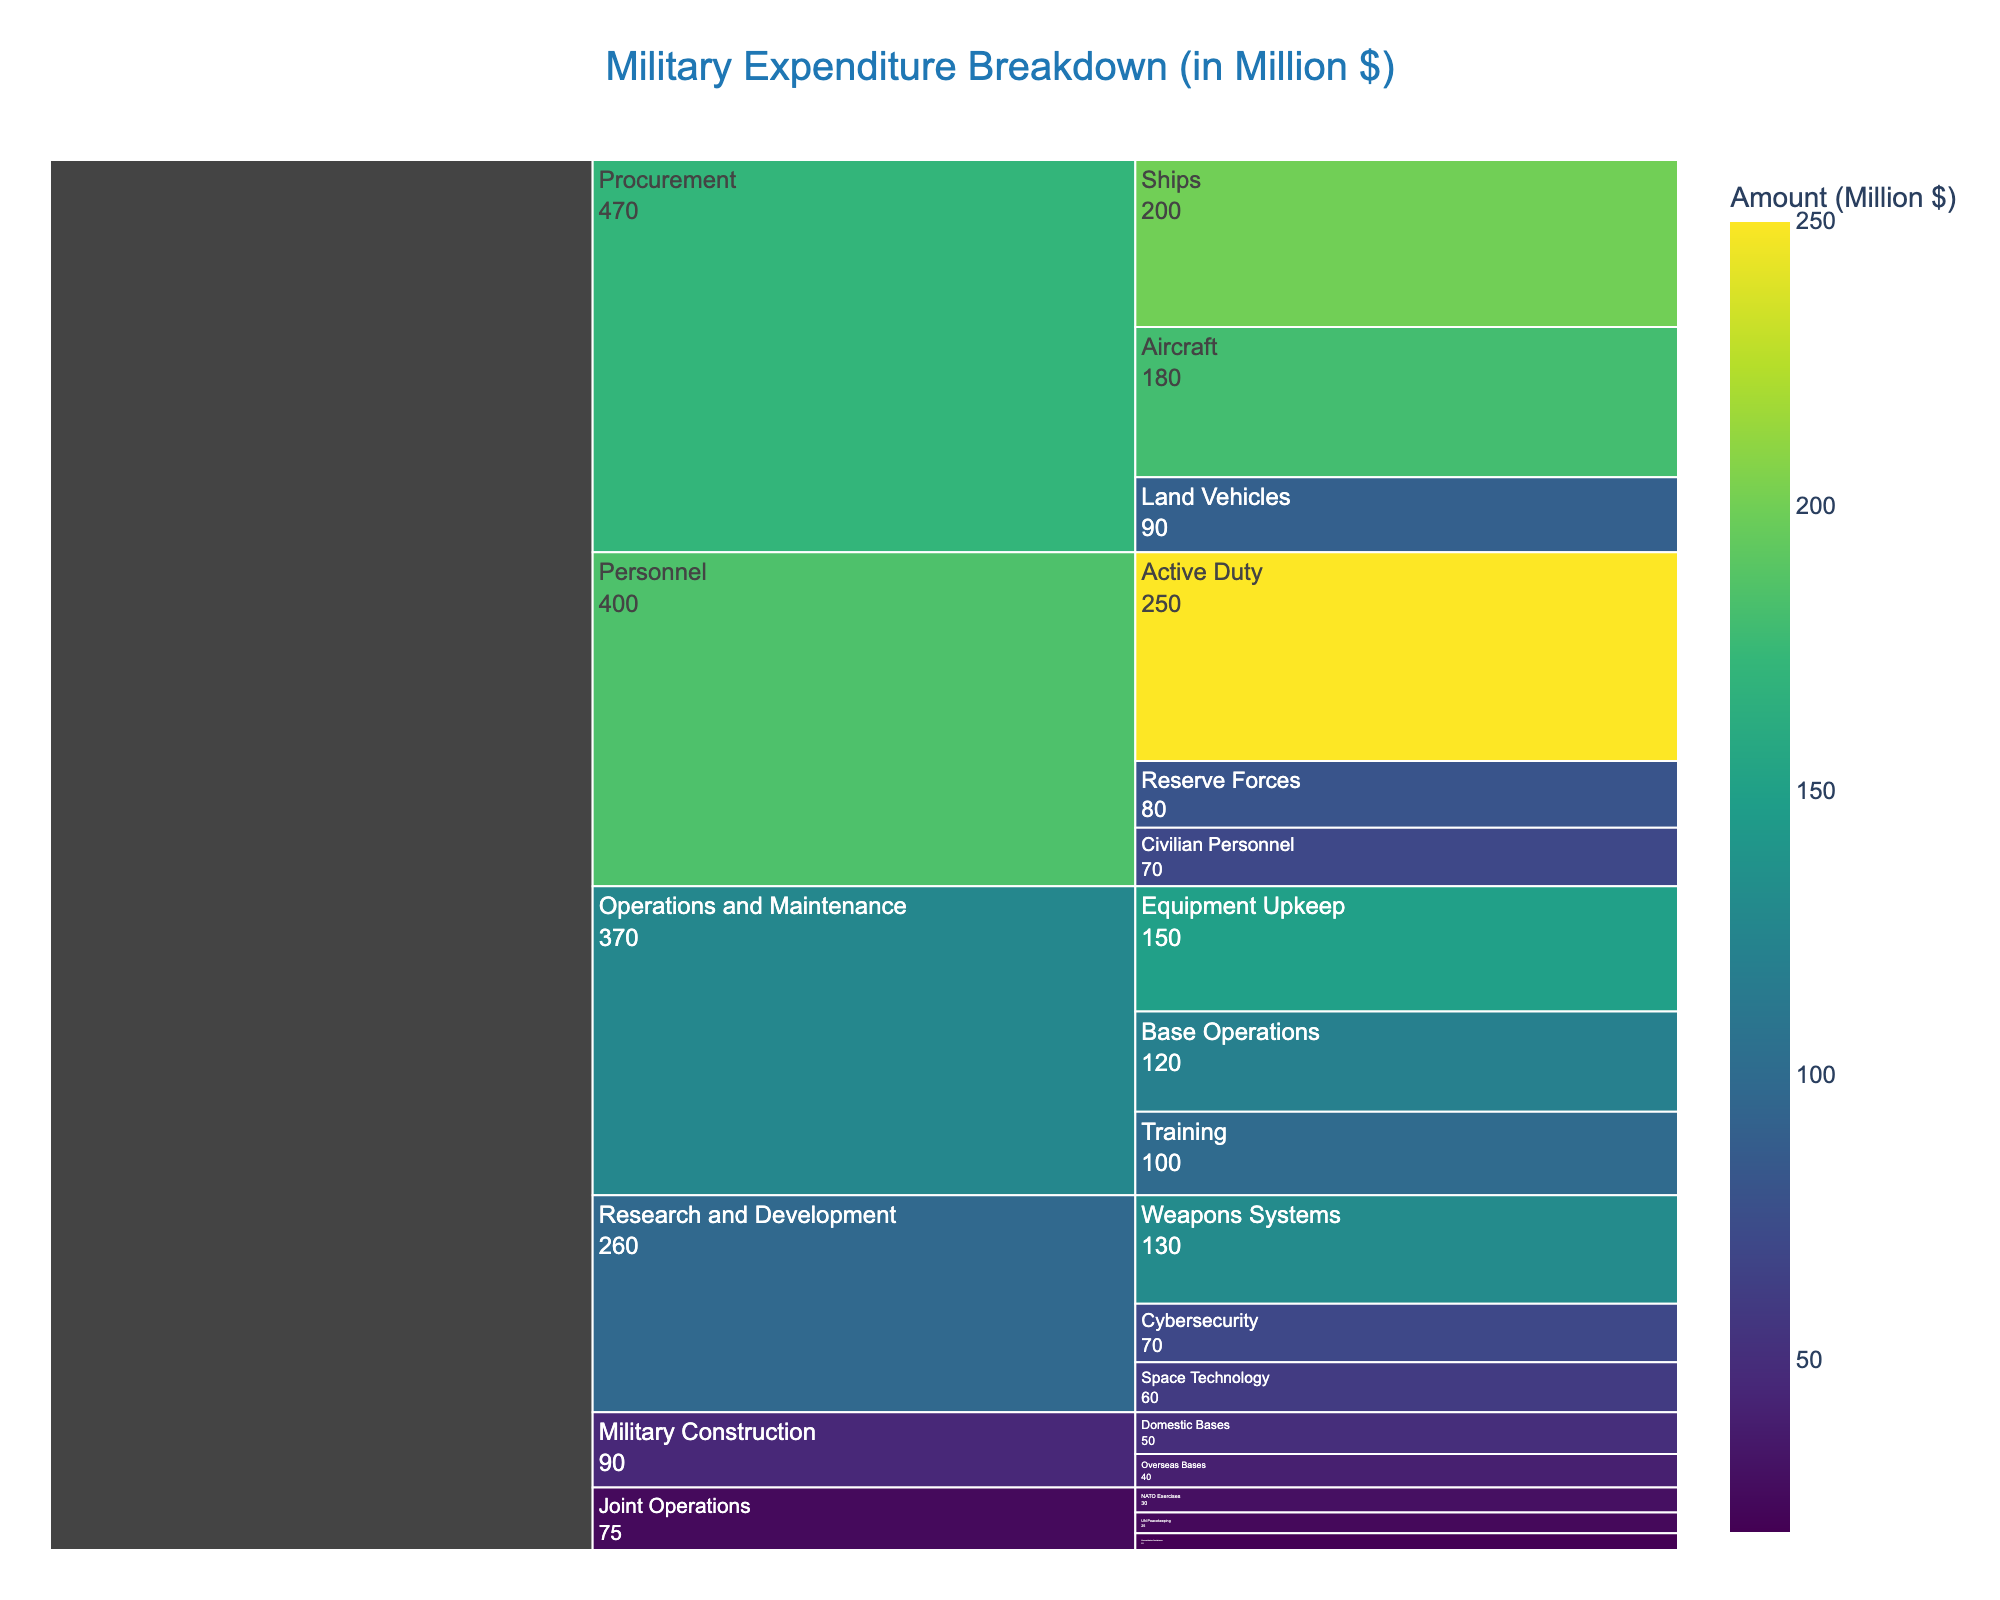What's the largest expenditure category? The largest category can be determined by looking at the segments in the Icicle chart and finding the one with the highest amount listed. The "Personnel" category has the highest expenditure.
Answer: Personnel Which subcategory under "Procurement" has the highest expenditure? Under the "Procurement" category, we compare the amounts of "Aircraft," "Ships," and "Land Vehicles." "Ships" has the highest amount at $200 million.
Answer: Ships What is the total expenditure for "Research and Development"? Add the amounts for all subcategories under "Research and Development": $130 million (Weapons Systems) + $70 million (Cybersecurity) + $60 million (Space Technology). The total is $260 million.
Answer: $260 million How does the expenditure for "Base Operations" compare to that for "Training"? The expenditure for "Base Operations" is $120 million, and for "Training" it is $100 million. Base Operations is higher.
Answer: Base Operations is higher Which department has the lowest total expenditure? Compare the total expenditures for all categories and find the lowest one. "Military Construction" has the lowest total with $50 million (Domestic Bases) + $40 million (Overseas Bases) = $90 million.
Answer: Military Construction How much more is spent on "Active Duty" compared to "Reserve Forces"? The expenditure for "Active Duty" is $250 million, and for "Reserve Forces" is $80 million. The difference is $250 million - $80 million.
Answer: $170 million What is the combined expenditure for "Joint Operations"? Add the amounts for all subcategories under "Joint Operations": $30 million (NATO Exercises) + $25 million (UN Peacekeeping) + $20 million (Humanitarian Assistance). The total is $75 million.
Answer: $75 million Which subcategory in "Research and Development" has the least expenditure? Under "Research and Development," we compare "Weapons Systems," "Cybersecurity," and "Space Technology." "Space Technology" has the least expenditure at $60 million.
Answer: Space Technology Is the expenditure on "Aircraft" greater than that on "Weapons Systems"? Compare the amounts of "Aircraft" ($180 million) and "Weapons Systems" ($130 million). "Aircraft" has a greater expenditure.
Answer: Yes How does the expenditure on "UN Peacekeeping" compare to "Humanitarian Assistance"? The expenditure for "UN Peacekeeping" is $25 million, and for "Humanitarian Assistance" it is $20 million. UN Peacekeeping is higher.
Answer: UN Peacekeeping is higher 